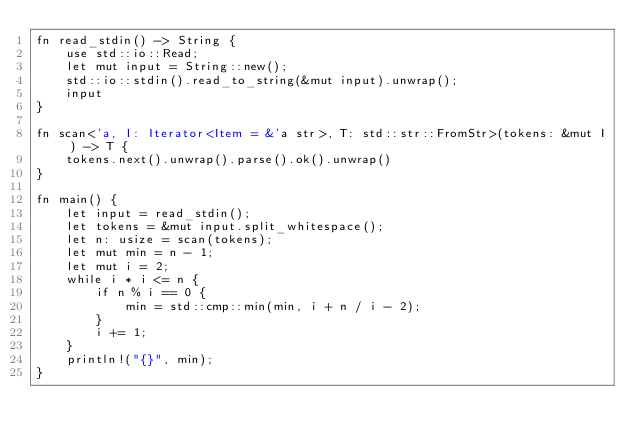<code> <loc_0><loc_0><loc_500><loc_500><_Rust_>fn read_stdin() -> String {
    use std::io::Read;
    let mut input = String::new();
    std::io::stdin().read_to_string(&mut input).unwrap();
    input
}

fn scan<'a, I: Iterator<Item = &'a str>, T: std::str::FromStr>(tokens: &mut I) -> T {
    tokens.next().unwrap().parse().ok().unwrap()
}

fn main() {
    let input = read_stdin();
    let tokens = &mut input.split_whitespace();
    let n: usize = scan(tokens);
    let mut min = n - 1;
    let mut i = 2;
    while i * i <= n {
        if n % i == 0 {
            min = std::cmp::min(min, i + n / i - 2);
        }
        i += 1;
    }
    println!("{}", min);
}
</code> 